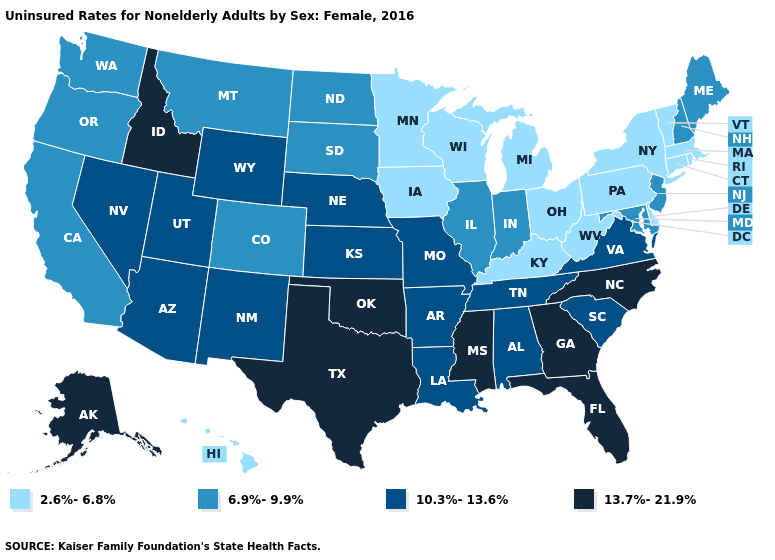Which states have the lowest value in the USA?
Quick response, please. Connecticut, Delaware, Hawaii, Iowa, Kentucky, Massachusetts, Michigan, Minnesota, New York, Ohio, Pennsylvania, Rhode Island, Vermont, West Virginia, Wisconsin. Does Ohio have a lower value than South Dakota?
Answer briefly. Yes. What is the value of Alaska?
Write a very short answer. 13.7%-21.9%. How many symbols are there in the legend?
Short answer required. 4. What is the value of Kansas?
Give a very brief answer. 10.3%-13.6%. What is the lowest value in the USA?
Be succinct. 2.6%-6.8%. What is the lowest value in the South?
Give a very brief answer. 2.6%-6.8%. Among the states that border Massachusetts , which have the lowest value?
Quick response, please. Connecticut, New York, Rhode Island, Vermont. Does New Jersey have the highest value in the Northeast?
Concise answer only. Yes. How many symbols are there in the legend?
Give a very brief answer. 4. Which states hav the highest value in the West?
Keep it brief. Alaska, Idaho. Which states hav the highest value in the South?
Answer briefly. Florida, Georgia, Mississippi, North Carolina, Oklahoma, Texas. Name the states that have a value in the range 6.9%-9.9%?
Give a very brief answer. California, Colorado, Illinois, Indiana, Maine, Maryland, Montana, New Hampshire, New Jersey, North Dakota, Oregon, South Dakota, Washington. Which states hav the highest value in the West?
Answer briefly. Alaska, Idaho. What is the value of Iowa?
Write a very short answer. 2.6%-6.8%. 